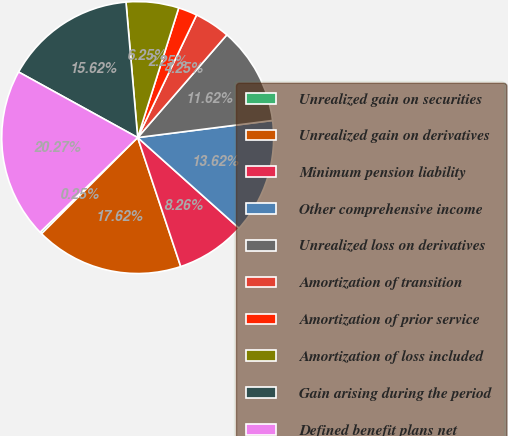Convert chart to OTSL. <chart><loc_0><loc_0><loc_500><loc_500><pie_chart><fcel>Unrealized gain on securities<fcel>Unrealized gain on derivatives<fcel>Minimum pension liability<fcel>Other comprehensive income<fcel>Unrealized loss on derivatives<fcel>Amortization of transition<fcel>Amortization of prior service<fcel>Amortization of loss included<fcel>Gain arising during the period<fcel>Defined benefit plans net<nl><fcel>0.25%<fcel>17.62%<fcel>8.26%<fcel>13.62%<fcel>11.62%<fcel>4.25%<fcel>2.25%<fcel>6.25%<fcel>15.62%<fcel>20.27%<nl></chart> 